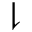<formula> <loc_0><loc_0><loc_500><loc_500>\downharpoonright</formula> 